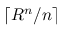<formula> <loc_0><loc_0><loc_500><loc_500>\lceil R ^ { n } / n \rceil</formula> 